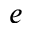<formula> <loc_0><loc_0><loc_500><loc_500>e</formula> 